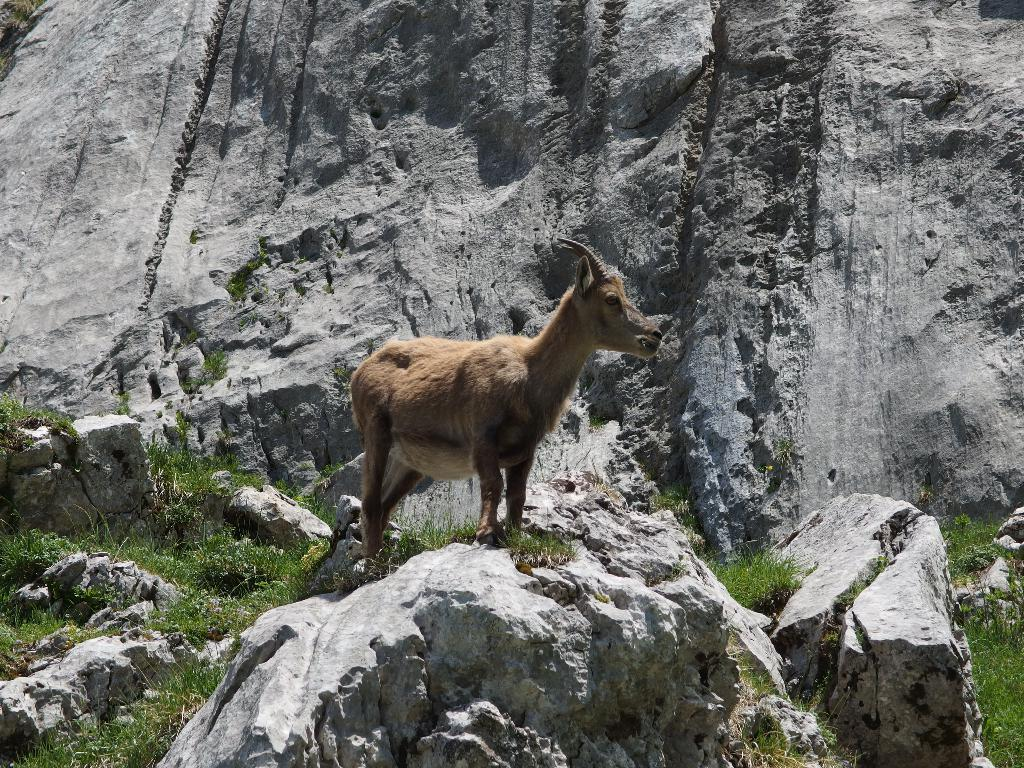What animal can be seen in the image? There is a deer in the image. Where is the deer located? The deer is standing on a mountain. What type of vegetation is present in the image? Grass is present in the image. When was the image taken? The image was taken during the day. Where was the image taken? The image was taken on a mountain. How many bikes are parked on the dock in the image? There are no bikes or docks present in the image; it features a deer standing on a mountain. 